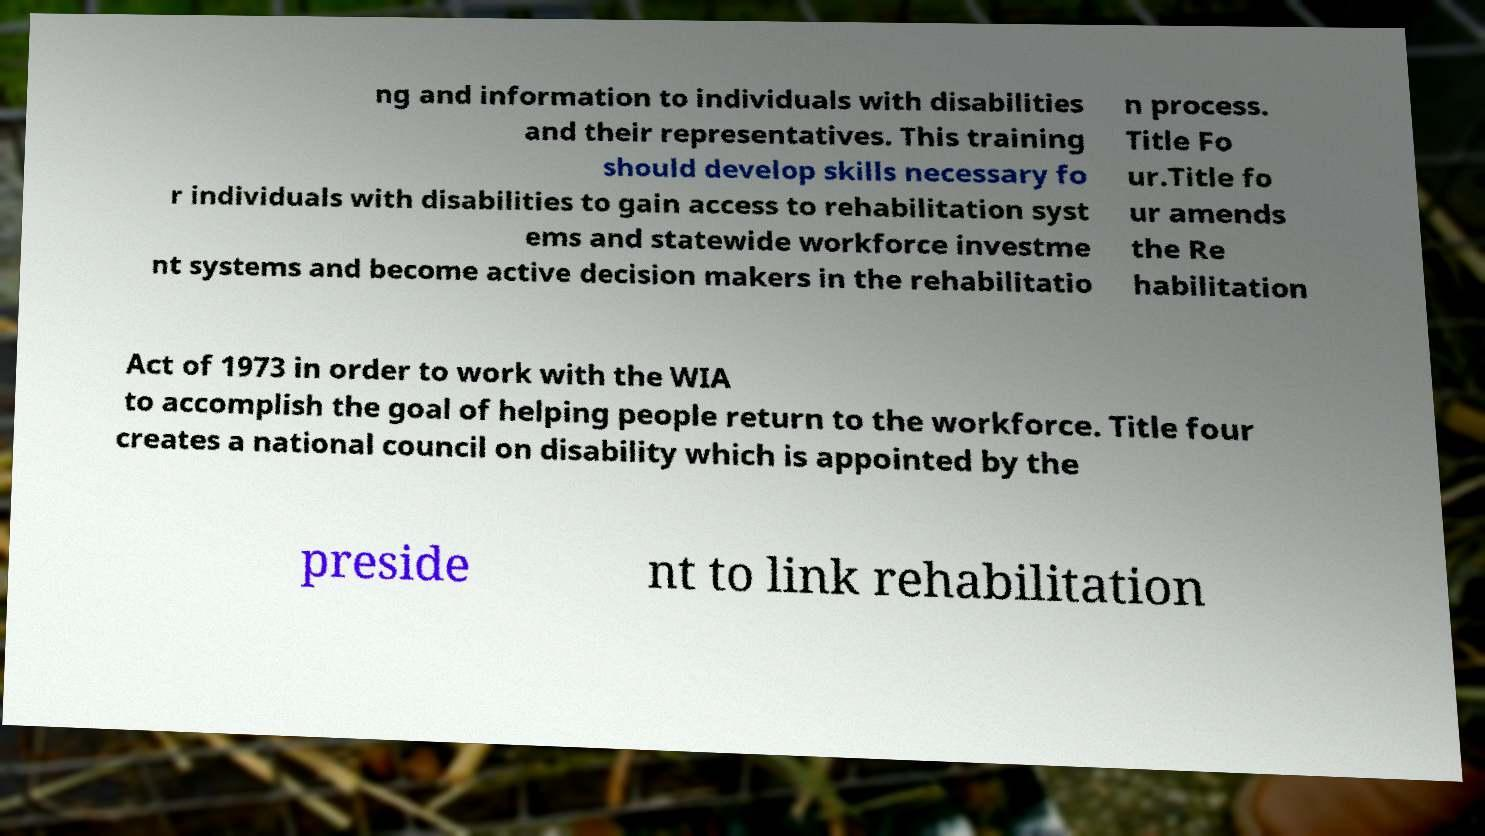Could you assist in decoding the text presented in this image and type it out clearly? ng and information to individuals with disabilities and their representatives. This training should develop skills necessary fo r individuals with disabilities to gain access to rehabilitation syst ems and statewide workforce investme nt systems and become active decision makers in the rehabilitatio n process. Title Fo ur.Title fo ur amends the Re habilitation Act of 1973 in order to work with the WIA to accomplish the goal of helping people return to the workforce. Title four creates a national council on disability which is appointed by the preside nt to link rehabilitation 